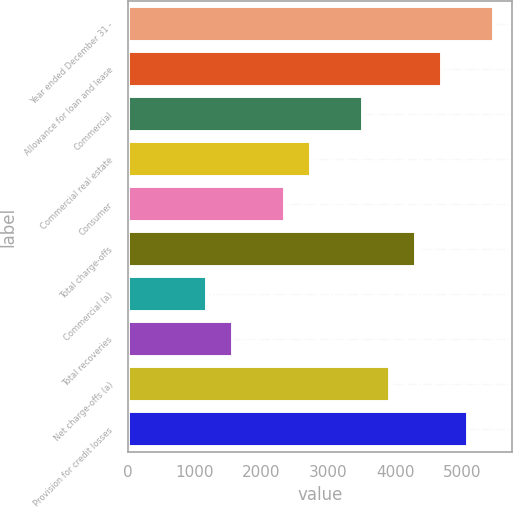Convert chart. <chart><loc_0><loc_0><loc_500><loc_500><bar_chart><fcel>Year ended December 31 -<fcel>Allowance for loan and lease<fcel>Commercial<fcel>Commercial real estate<fcel>Consumer<fcel>Total charge-offs<fcel>Commercial (a)<fcel>Total recoveries<fcel>Net charge-offs (a)<fcel>Provision for credit losses<nl><fcel>5482.95<fcel>4699.97<fcel>3525.5<fcel>2742.52<fcel>2351.03<fcel>4308.48<fcel>1176.56<fcel>1568.05<fcel>3916.99<fcel>5091.46<nl></chart> 